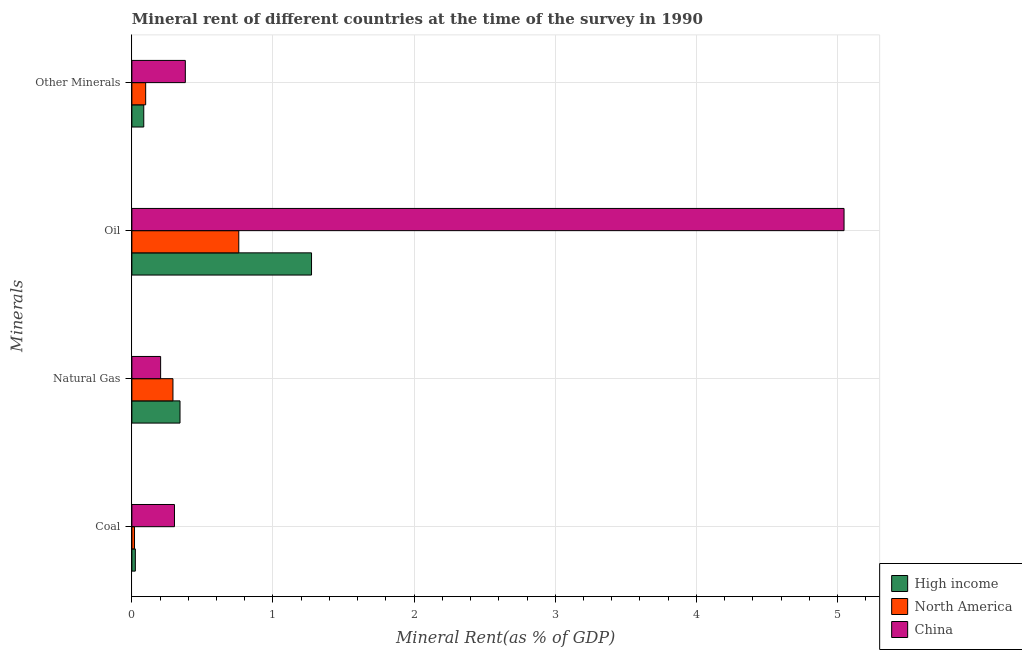How many groups of bars are there?
Offer a very short reply. 4. Are the number of bars on each tick of the Y-axis equal?
Offer a terse response. Yes. How many bars are there on the 4th tick from the bottom?
Your answer should be very brief. 3. What is the label of the 4th group of bars from the top?
Give a very brief answer. Coal. What is the coal rent in North America?
Keep it short and to the point. 0.02. Across all countries, what is the maximum oil rent?
Your response must be concise. 5.05. Across all countries, what is the minimum  rent of other minerals?
Provide a short and direct response. 0.08. What is the total  rent of other minerals in the graph?
Provide a short and direct response. 0.56. What is the difference between the coal rent in China and that in High income?
Your answer should be very brief. 0.28. What is the difference between the oil rent in China and the natural gas rent in High income?
Offer a very short reply. 4.71. What is the average coal rent per country?
Offer a very short reply. 0.12. What is the difference between the coal rent and natural gas rent in High income?
Keep it short and to the point. -0.32. In how many countries, is the oil rent greater than 3.2 %?
Ensure brevity in your answer.  1. What is the ratio of the coal rent in High income to that in North America?
Give a very brief answer. 1.31. Is the oil rent in North America less than that in High income?
Provide a short and direct response. Yes. What is the difference between the highest and the second highest oil rent?
Make the answer very short. 3.77. What is the difference between the highest and the lowest oil rent?
Ensure brevity in your answer.  4.29. In how many countries, is the coal rent greater than the average coal rent taken over all countries?
Your answer should be compact. 1. Is it the case that in every country, the sum of the natural gas rent and coal rent is greater than the sum of oil rent and  rent of other minerals?
Provide a succinct answer. Yes. What is the difference between two consecutive major ticks on the X-axis?
Provide a succinct answer. 1. Does the graph contain any zero values?
Give a very brief answer. No. Does the graph contain grids?
Offer a very short reply. Yes. Where does the legend appear in the graph?
Your answer should be very brief. Bottom right. How many legend labels are there?
Your answer should be very brief. 3. How are the legend labels stacked?
Make the answer very short. Vertical. What is the title of the graph?
Make the answer very short. Mineral rent of different countries at the time of the survey in 1990. Does "Portugal" appear as one of the legend labels in the graph?
Offer a very short reply. No. What is the label or title of the X-axis?
Your response must be concise. Mineral Rent(as % of GDP). What is the label or title of the Y-axis?
Offer a terse response. Minerals. What is the Mineral Rent(as % of GDP) of High income in Coal?
Offer a terse response. 0.02. What is the Mineral Rent(as % of GDP) of North America in Coal?
Keep it short and to the point. 0.02. What is the Mineral Rent(as % of GDP) of China in Coal?
Your answer should be very brief. 0.3. What is the Mineral Rent(as % of GDP) in High income in Natural Gas?
Ensure brevity in your answer.  0.34. What is the Mineral Rent(as % of GDP) of North America in Natural Gas?
Your answer should be very brief. 0.29. What is the Mineral Rent(as % of GDP) in China in Natural Gas?
Offer a very short reply. 0.2. What is the Mineral Rent(as % of GDP) of High income in Oil?
Offer a very short reply. 1.27. What is the Mineral Rent(as % of GDP) of North America in Oil?
Your answer should be very brief. 0.76. What is the Mineral Rent(as % of GDP) of China in Oil?
Your response must be concise. 5.05. What is the Mineral Rent(as % of GDP) of High income in Other Minerals?
Make the answer very short. 0.08. What is the Mineral Rent(as % of GDP) in North America in Other Minerals?
Offer a very short reply. 0.1. What is the Mineral Rent(as % of GDP) in China in Other Minerals?
Keep it short and to the point. 0.38. Across all Minerals, what is the maximum Mineral Rent(as % of GDP) in High income?
Give a very brief answer. 1.27. Across all Minerals, what is the maximum Mineral Rent(as % of GDP) in North America?
Your response must be concise. 0.76. Across all Minerals, what is the maximum Mineral Rent(as % of GDP) in China?
Offer a terse response. 5.05. Across all Minerals, what is the minimum Mineral Rent(as % of GDP) of High income?
Offer a very short reply. 0.02. Across all Minerals, what is the minimum Mineral Rent(as % of GDP) of North America?
Provide a short and direct response. 0.02. Across all Minerals, what is the minimum Mineral Rent(as % of GDP) in China?
Your response must be concise. 0.2. What is the total Mineral Rent(as % of GDP) of High income in the graph?
Your response must be concise. 1.72. What is the total Mineral Rent(as % of GDP) in North America in the graph?
Keep it short and to the point. 1.17. What is the total Mineral Rent(as % of GDP) in China in the graph?
Offer a very short reply. 5.93. What is the difference between the Mineral Rent(as % of GDP) in High income in Coal and that in Natural Gas?
Provide a short and direct response. -0.32. What is the difference between the Mineral Rent(as % of GDP) in North America in Coal and that in Natural Gas?
Offer a terse response. -0.27. What is the difference between the Mineral Rent(as % of GDP) in China in Coal and that in Natural Gas?
Provide a succinct answer. 0.1. What is the difference between the Mineral Rent(as % of GDP) of High income in Coal and that in Oil?
Your answer should be compact. -1.25. What is the difference between the Mineral Rent(as % of GDP) of North America in Coal and that in Oil?
Offer a very short reply. -0.74. What is the difference between the Mineral Rent(as % of GDP) of China in Coal and that in Oil?
Offer a terse response. -4.74. What is the difference between the Mineral Rent(as % of GDP) of High income in Coal and that in Other Minerals?
Make the answer very short. -0.06. What is the difference between the Mineral Rent(as % of GDP) in North America in Coal and that in Other Minerals?
Provide a succinct answer. -0.08. What is the difference between the Mineral Rent(as % of GDP) in China in Coal and that in Other Minerals?
Make the answer very short. -0.08. What is the difference between the Mineral Rent(as % of GDP) of High income in Natural Gas and that in Oil?
Your response must be concise. -0.93. What is the difference between the Mineral Rent(as % of GDP) in North America in Natural Gas and that in Oil?
Make the answer very short. -0.47. What is the difference between the Mineral Rent(as % of GDP) of China in Natural Gas and that in Oil?
Offer a very short reply. -4.84. What is the difference between the Mineral Rent(as % of GDP) in High income in Natural Gas and that in Other Minerals?
Make the answer very short. 0.26. What is the difference between the Mineral Rent(as % of GDP) of North America in Natural Gas and that in Other Minerals?
Offer a very short reply. 0.19. What is the difference between the Mineral Rent(as % of GDP) in China in Natural Gas and that in Other Minerals?
Your answer should be very brief. -0.18. What is the difference between the Mineral Rent(as % of GDP) in High income in Oil and that in Other Minerals?
Provide a succinct answer. 1.19. What is the difference between the Mineral Rent(as % of GDP) in North America in Oil and that in Other Minerals?
Offer a terse response. 0.66. What is the difference between the Mineral Rent(as % of GDP) in China in Oil and that in Other Minerals?
Offer a terse response. 4.67. What is the difference between the Mineral Rent(as % of GDP) of High income in Coal and the Mineral Rent(as % of GDP) of North America in Natural Gas?
Your answer should be very brief. -0.27. What is the difference between the Mineral Rent(as % of GDP) of High income in Coal and the Mineral Rent(as % of GDP) of China in Natural Gas?
Ensure brevity in your answer.  -0.18. What is the difference between the Mineral Rent(as % of GDP) in North America in Coal and the Mineral Rent(as % of GDP) in China in Natural Gas?
Keep it short and to the point. -0.18. What is the difference between the Mineral Rent(as % of GDP) of High income in Coal and the Mineral Rent(as % of GDP) of North America in Oil?
Make the answer very short. -0.73. What is the difference between the Mineral Rent(as % of GDP) in High income in Coal and the Mineral Rent(as % of GDP) in China in Oil?
Provide a short and direct response. -5.02. What is the difference between the Mineral Rent(as % of GDP) in North America in Coal and the Mineral Rent(as % of GDP) in China in Oil?
Offer a terse response. -5.03. What is the difference between the Mineral Rent(as % of GDP) of High income in Coal and the Mineral Rent(as % of GDP) of North America in Other Minerals?
Give a very brief answer. -0.07. What is the difference between the Mineral Rent(as % of GDP) of High income in Coal and the Mineral Rent(as % of GDP) of China in Other Minerals?
Your answer should be compact. -0.35. What is the difference between the Mineral Rent(as % of GDP) in North America in Coal and the Mineral Rent(as % of GDP) in China in Other Minerals?
Offer a terse response. -0.36. What is the difference between the Mineral Rent(as % of GDP) in High income in Natural Gas and the Mineral Rent(as % of GDP) in North America in Oil?
Provide a succinct answer. -0.42. What is the difference between the Mineral Rent(as % of GDP) in High income in Natural Gas and the Mineral Rent(as % of GDP) in China in Oil?
Provide a succinct answer. -4.71. What is the difference between the Mineral Rent(as % of GDP) in North America in Natural Gas and the Mineral Rent(as % of GDP) in China in Oil?
Provide a short and direct response. -4.76. What is the difference between the Mineral Rent(as % of GDP) of High income in Natural Gas and the Mineral Rent(as % of GDP) of North America in Other Minerals?
Your response must be concise. 0.24. What is the difference between the Mineral Rent(as % of GDP) of High income in Natural Gas and the Mineral Rent(as % of GDP) of China in Other Minerals?
Your response must be concise. -0.04. What is the difference between the Mineral Rent(as % of GDP) in North America in Natural Gas and the Mineral Rent(as % of GDP) in China in Other Minerals?
Ensure brevity in your answer.  -0.09. What is the difference between the Mineral Rent(as % of GDP) in High income in Oil and the Mineral Rent(as % of GDP) in North America in Other Minerals?
Ensure brevity in your answer.  1.18. What is the difference between the Mineral Rent(as % of GDP) of High income in Oil and the Mineral Rent(as % of GDP) of China in Other Minerals?
Provide a succinct answer. 0.89. What is the difference between the Mineral Rent(as % of GDP) in North America in Oil and the Mineral Rent(as % of GDP) in China in Other Minerals?
Make the answer very short. 0.38. What is the average Mineral Rent(as % of GDP) of High income per Minerals?
Keep it short and to the point. 0.43. What is the average Mineral Rent(as % of GDP) in North America per Minerals?
Your answer should be very brief. 0.29. What is the average Mineral Rent(as % of GDP) of China per Minerals?
Your answer should be compact. 1.48. What is the difference between the Mineral Rent(as % of GDP) of High income and Mineral Rent(as % of GDP) of North America in Coal?
Keep it short and to the point. 0.01. What is the difference between the Mineral Rent(as % of GDP) in High income and Mineral Rent(as % of GDP) in China in Coal?
Ensure brevity in your answer.  -0.28. What is the difference between the Mineral Rent(as % of GDP) in North America and Mineral Rent(as % of GDP) in China in Coal?
Offer a terse response. -0.28. What is the difference between the Mineral Rent(as % of GDP) in High income and Mineral Rent(as % of GDP) in North America in Natural Gas?
Keep it short and to the point. 0.05. What is the difference between the Mineral Rent(as % of GDP) of High income and Mineral Rent(as % of GDP) of China in Natural Gas?
Ensure brevity in your answer.  0.14. What is the difference between the Mineral Rent(as % of GDP) of North America and Mineral Rent(as % of GDP) of China in Natural Gas?
Make the answer very short. 0.09. What is the difference between the Mineral Rent(as % of GDP) of High income and Mineral Rent(as % of GDP) of North America in Oil?
Offer a terse response. 0.52. What is the difference between the Mineral Rent(as % of GDP) in High income and Mineral Rent(as % of GDP) in China in Oil?
Provide a succinct answer. -3.77. What is the difference between the Mineral Rent(as % of GDP) in North America and Mineral Rent(as % of GDP) in China in Oil?
Give a very brief answer. -4.29. What is the difference between the Mineral Rent(as % of GDP) in High income and Mineral Rent(as % of GDP) in North America in Other Minerals?
Offer a terse response. -0.01. What is the difference between the Mineral Rent(as % of GDP) in High income and Mineral Rent(as % of GDP) in China in Other Minerals?
Offer a very short reply. -0.29. What is the difference between the Mineral Rent(as % of GDP) of North America and Mineral Rent(as % of GDP) of China in Other Minerals?
Offer a very short reply. -0.28. What is the ratio of the Mineral Rent(as % of GDP) in High income in Coal to that in Natural Gas?
Keep it short and to the point. 0.07. What is the ratio of the Mineral Rent(as % of GDP) in North America in Coal to that in Natural Gas?
Make the answer very short. 0.06. What is the ratio of the Mineral Rent(as % of GDP) of China in Coal to that in Natural Gas?
Make the answer very short. 1.48. What is the ratio of the Mineral Rent(as % of GDP) in High income in Coal to that in Oil?
Your answer should be compact. 0.02. What is the ratio of the Mineral Rent(as % of GDP) of North America in Coal to that in Oil?
Provide a short and direct response. 0.02. What is the ratio of the Mineral Rent(as % of GDP) in China in Coal to that in Oil?
Your answer should be very brief. 0.06. What is the ratio of the Mineral Rent(as % of GDP) in High income in Coal to that in Other Minerals?
Make the answer very short. 0.29. What is the ratio of the Mineral Rent(as % of GDP) in North America in Coal to that in Other Minerals?
Provide a short and direct response. 0.19. What is the ratio of the Mineral Rent(as % of GDP) in China in Coal to that in Other Minerals?
Give a very brief answer. 0.8. What is the ratio of the Mineral Rent(as % of GDP) of High income in Natural Gas to that in Oil?
Give a very brief answer. 0.27. What is the ratio of the Mineral Rent(as % of GDP) in North America in Natural Gas to that in Oil?
Give a very brief answer. 0.38. What is the ratio of the Mineral Rent(as % of GDP) in China in Natural Gas to that in Oil?
Give a very brief answer. 0.04. What is the ratio of the Mineral Rent(as % of GDP) of High income in Natural Gas to that in Other Minerals?
Offer a very short reply. 4.05. What is the ratio of the Mineral Rent(as % of GDP) in North America in Natural Gas to that in Other Minerals?
Provide a succinct answer. 2.98. What is the ratio of the Mineral Rent(as % of GDP) in China in Natural Gas to that in Other Minerals?
Ensure brevity in your answer.  0.54. What is the ratio of the Mineral Rent(as % of GDP) of High income in Oil to that in Other Minerals?
Your answer should be very brief. 15.11. What is the ratio of the Mineral Rent(as % of GDP) of North America in Oil to that in Other Minerals?
Your answer should be compact. 7.75. What is the ratio of the Mineral Rent(as % of GDP) of China in Oil to that in Other Minerals?
Keep it short and to the point. 13.32. What is the difference between the highest and the second highest Mineral Rent(as % of GDP) of High income?
Offer a terse response. 0.93. What is the difference between the highest and the second highest Mineral Rent(as % of GDP) of North America?
Keep it short and to the point. 0.47. What is the difference between the highest and the second highest Mineral Rent(as % of GDP) in China?
Offer a terse response. 4.67. What is the difference between the highest and the lowest Mineral Rent(as % of GDP) in High income?
Ensure brevity in your answer.  1.25. What is the difference between the highest and the lowest Mineral Rent(as % of GDP) of North America?
Ensure brevity in your answer.  0.74. What is the difference between the highest and the lowest Mineral Rent(as % of GDP) of China?
Provide a succinct answer. 4.84. 